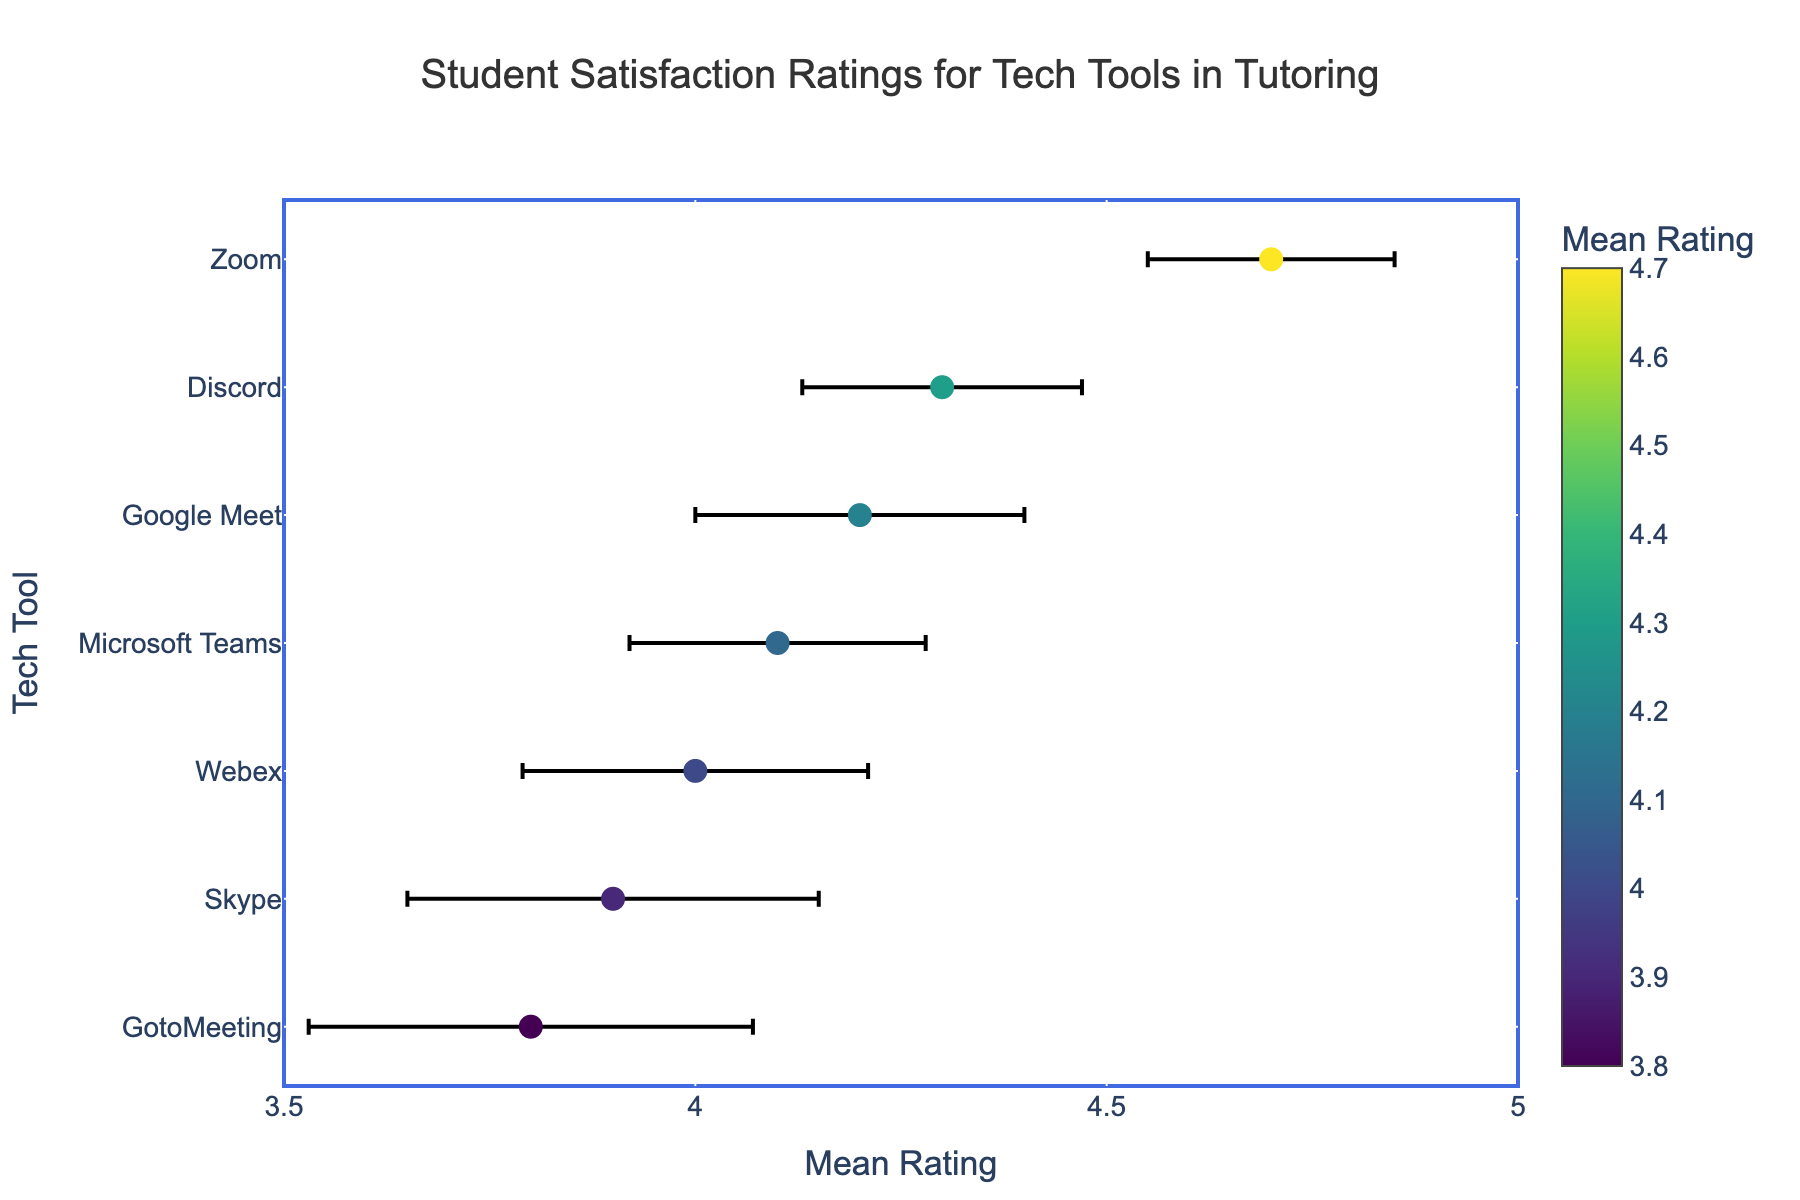How many tech tools were rated in the figure? Count the number of unique tech tools listed on the y-axis. There are seven tools: Zoom, Google Meet, Microsoft Teams, Skype, Discord, GotoMeeting, and Webex.
Answer: Seven Which tech tool has the highest mean satisfaction rating? Look for the dot that is furthest to the right (highest mean rating) among all the tools listed. Zoom has the highest mean rating at 4.7.
Answer: Zoom Which tech tool has the highest standard error in its rating? Identify the tool whose error bar extends the furthest from its mean rating dot. GotoMeeting has the highest standard error, with an error bar of 0.27.
Answer: GotoMeeting What's the range of the mean ratings for all tech tools? Determine the difference between the highest and lowest mean rating values. The highest mean rating is 4.7 (Zoom) and the lowest is 3.8 (GotoMeeting), so the range is 4.7 - 3.8.
Answer: 0.9 What is the mean rating of Skype relative to Webex? Compare the mean rating values of Skype and Webex directly. Skype has a mean rating of 3.9, and Webex has a mean rating of 4.0.
Answer: Skype is 0.1 lower Which tool has the narrowest error bar? Identify the tool with the smallest range from its mean dot due to the error bars. Zoom has the smallest standard error of 0.15, making its error bar the narrowest.
Answer: Zoom What is the difference in mean rating between Google Meet and Microsoft Teams? Subtract the mean rating of Microsoft Teams (4.1) from that of Google Meet (4.2). The difference is 4.2 - 4.1.
Answer: 0.1 How do Zoom and Discord compare in terms of mean rating and standard error? Zoom has a mean rating of 4.7 with a 0.15 standard error. Discord has a mean rating of 4.3 with a 0.17 standard error. Zoom has a higher mean rating by 0.4 and a slightly smaller standard error by 0.02.
Answer: Zoom is higher by 0.4; error lower by 0.02 Is there any tech tool with a mean rating exactly between 4.0 and 4.5? Identify if any tool’s mean rating falls between 4.0 and 4.5. Google Meet, Microsoft Teams, and Discord have mean ratings within this range (4.2, 4.1, and 4.3, respectively).
Answer: Google Meet, Microsoft Teams, Discord 